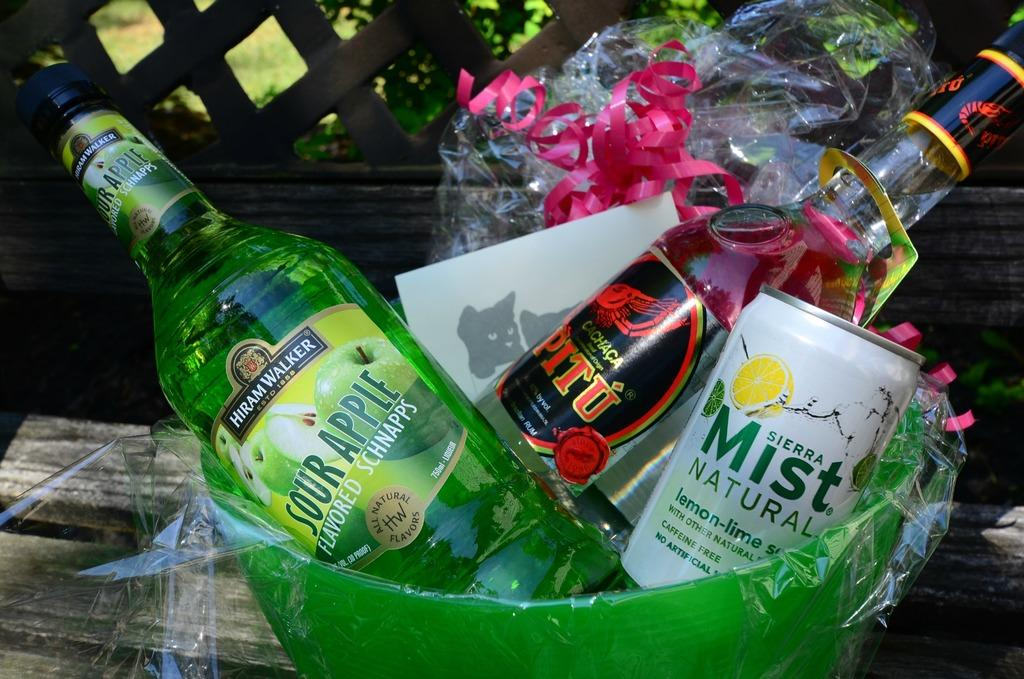Provide a one-sentence caption for the provided image. a drink basket with Sierra Mist Natural and Sour apple Flavored Schnapps. 